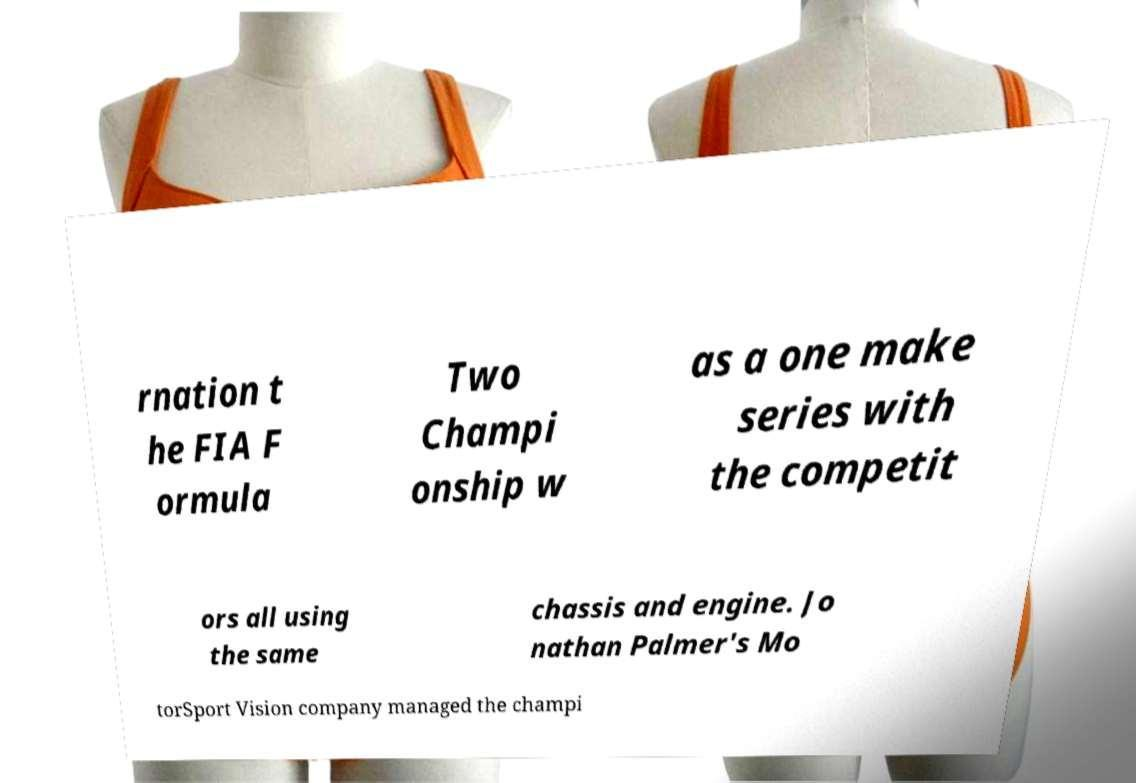I need the written content from this picture converted into text. Can you do that? rnation t he FIA F ormula Two Champi onship w as a one make series with the competit ors all using the same chassis and engine. Jo nathan Palmer's Mo torSport Vision company managed the champi 